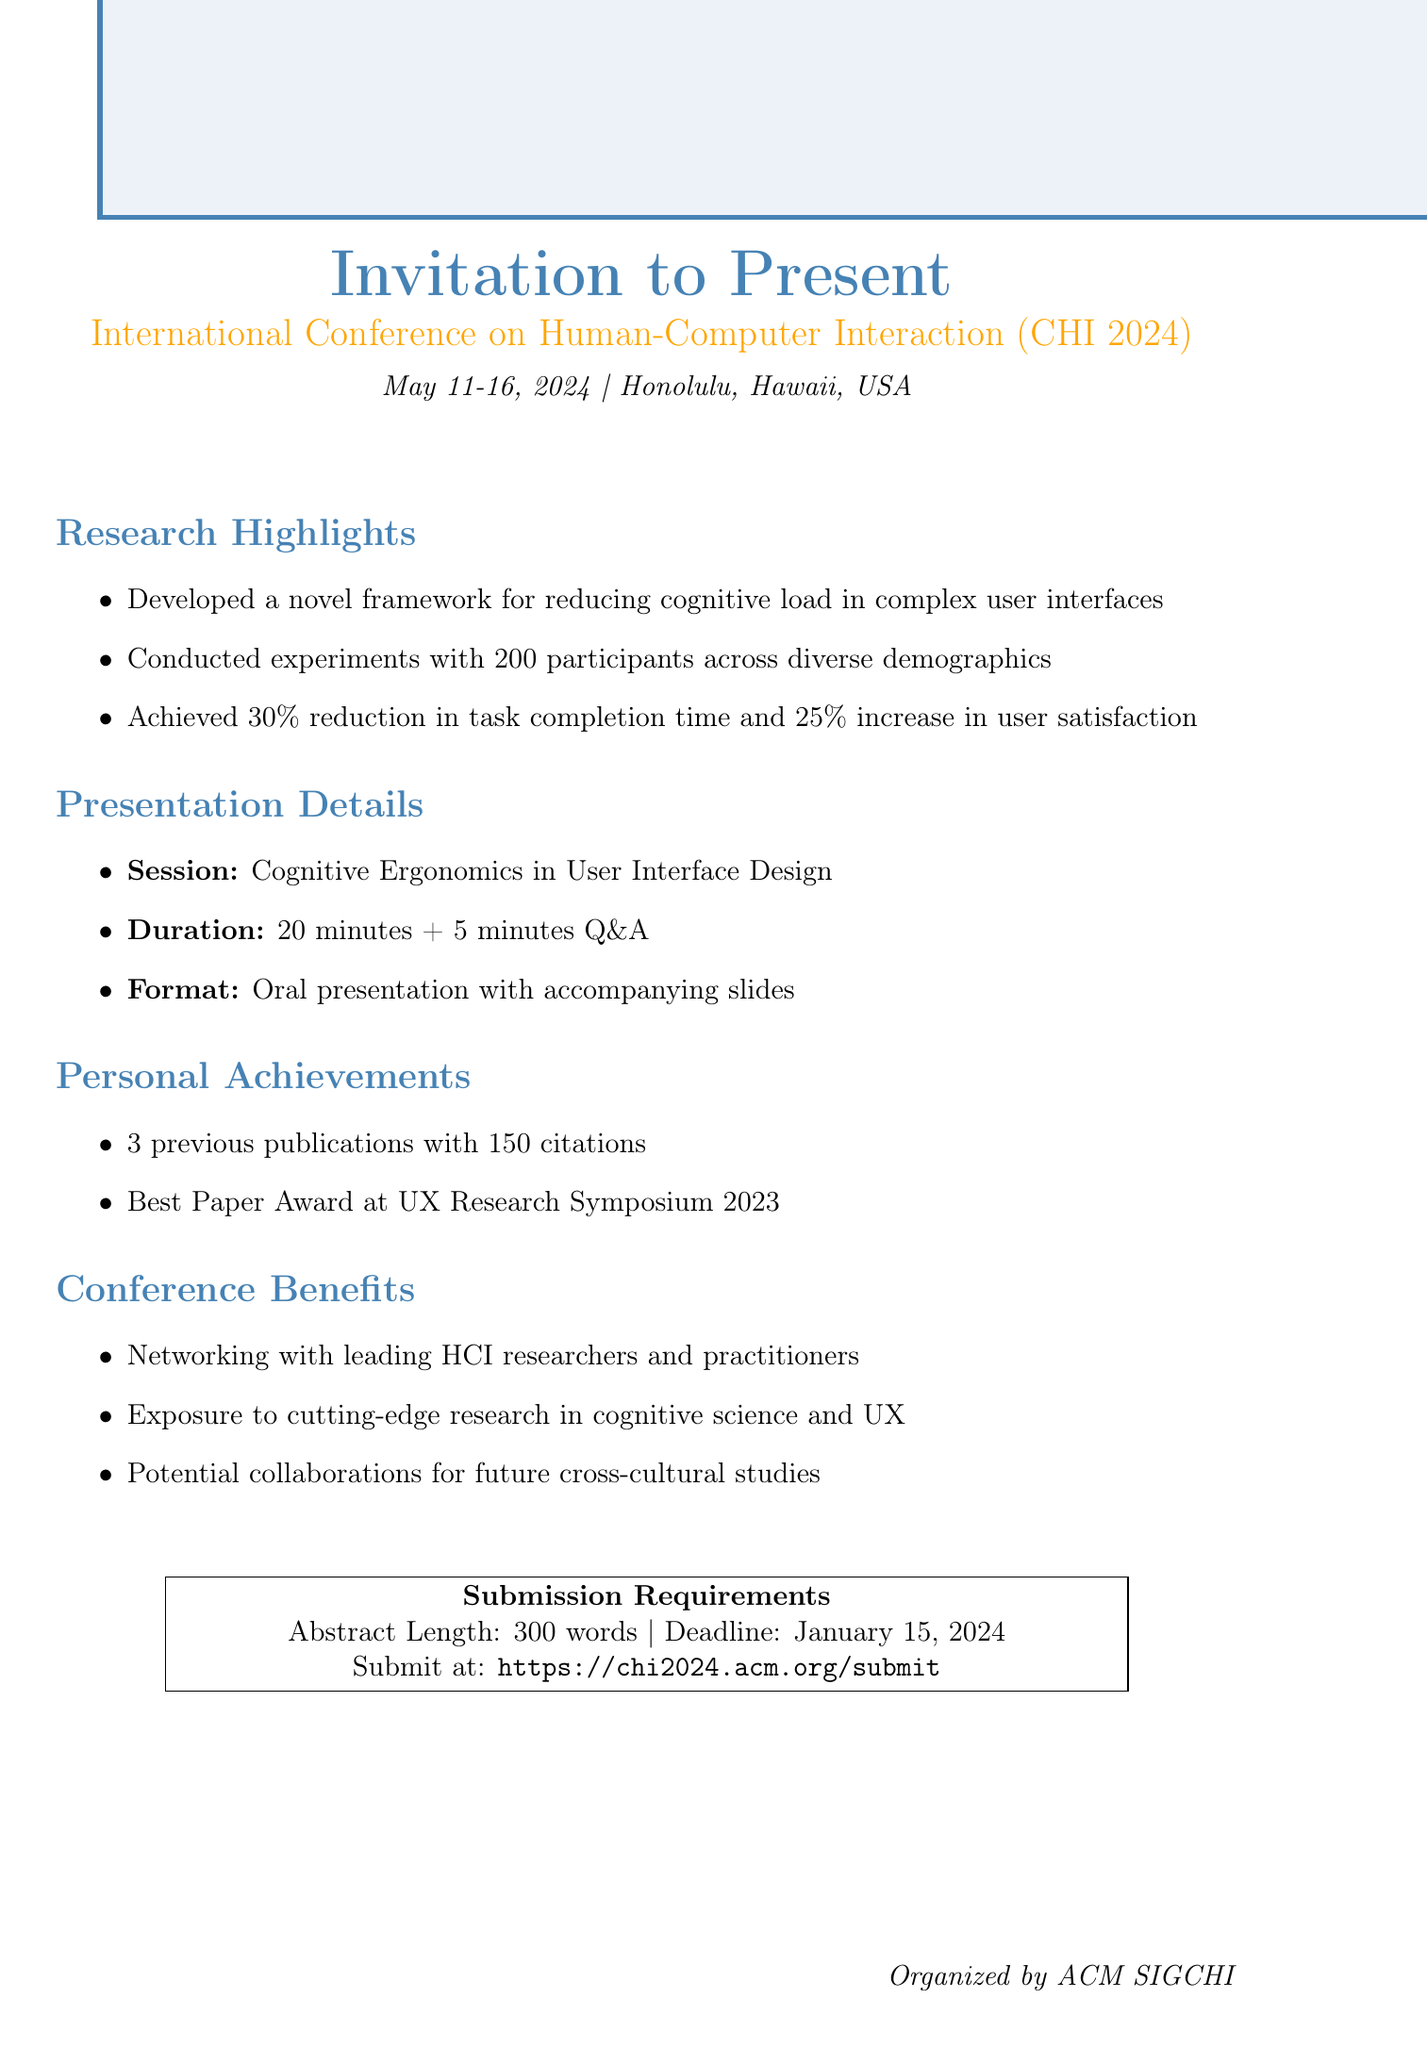What is the name of the conference? The first line of the document states the name of the conference, which is "International Conference on Human-Computer Interaction (CHI 2024)".
Answer: International Conference on Human-Computer Interaction (CHI 2024) When is the conference scheduled? The date is mentioned in the introductory section of the document: "May 11-16, 2024".
Answer: May 11-16, 2024 Where is the conference taking place? The location of the conference is specified as "Honolulu, Hawaii, USA".
Answer: Honolulu, Hawaii, USA What is the submission deadline for the abstract? The document clearly states the submission deadline as "January 15, 2024".
Answer: January 15, 2024 How long is the presentation duration? The duration of the presentation is provided as "20 minutes + 5 minutes Q&A" in the presentation details section.
Answer: 20 minutes + 5 minutes Q&A What is one key finding from the research? A highlighted research finding is mentioned: "Achieved a 30% reduction in task completion time".
Answer: 30% reduction in task completion time How many participants were involved in the experiments? The document indicates that "200 participants" were involved in the experiments conducted.
Answer: 200 participants What award did the researcher receive in 2023? The personal achievements section states the award won: "Best Paper Award at UX Research Symposium 2023".
Answer: Best Paper Award at UX Research Symposium 2023 What is one benefit of attending the conference? The conference benefits mention "Networking opportunities with leading HCI researchers and practitioners".
Answer: Networking opportunities with leading HCI researchers and practitioners 